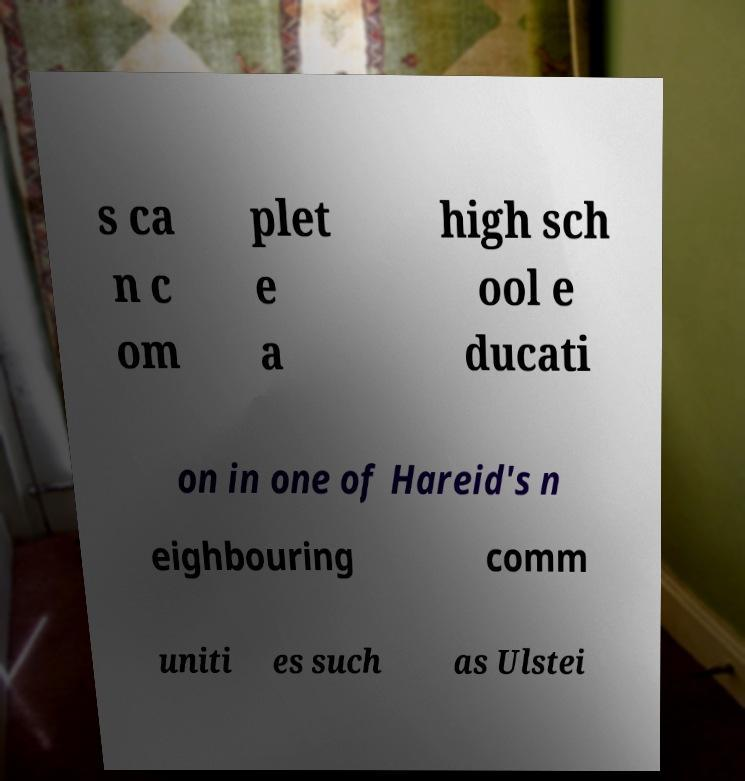Please read and relay the text visible in this image. What does it say? s ca n c om plet e a high sch ool e ducati on in one of Hareid's n eighbouring comm uniti es such as Ulstei 